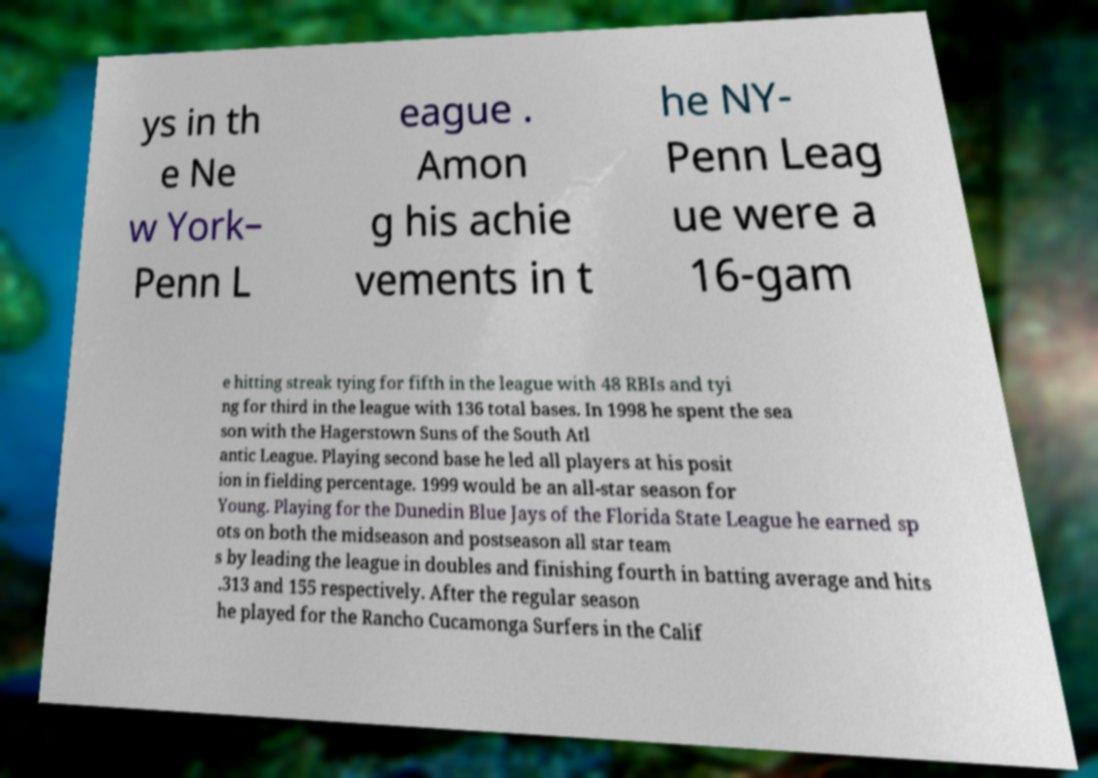Could you extract and type out the text from this image? ys in th e Ne w York– Penn L eague . Amon g his achie vements in t he NY- Penn Leag ue were a 16-gam e hitting streak tying for fifth in the league with 48 RBIs and tyi ng for third in the league with 136 total bases. In 1998 he spent the sea son with the Hagerstown Suns of the South Atl antic League. Playing second base he led all players at his posit ion in fielding percentage. 1999 would be an all-star season for Young. Playing for the Dunedin Blue Jays of the Florida State League he earned sp ots on both the midseason and postseason all star team s by leading the league in doubles and finishing fourth in batting average and hits .313 and 155 respectively. After the regular season he played for the Rancho Cucamonga Surfers in the Calif 